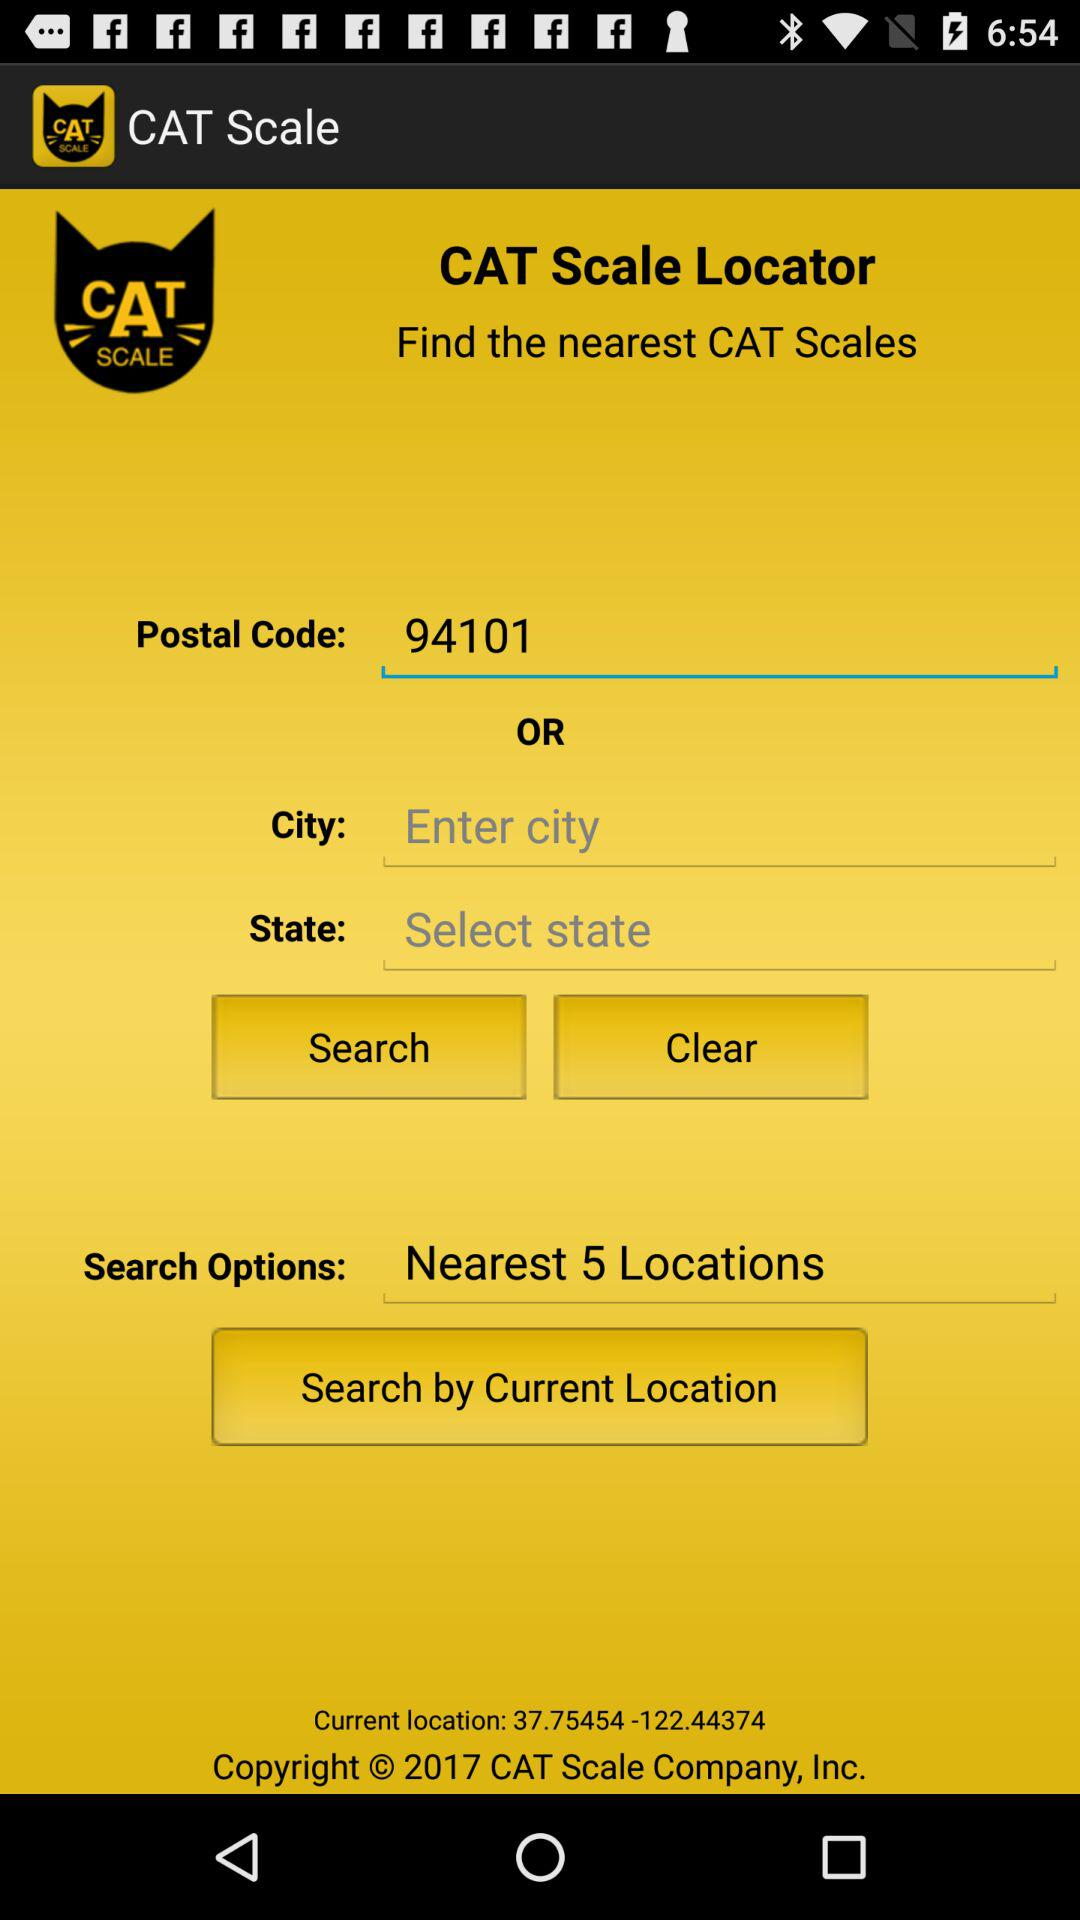What code is entered in the "Postal Code"? The entered code is 94101. 